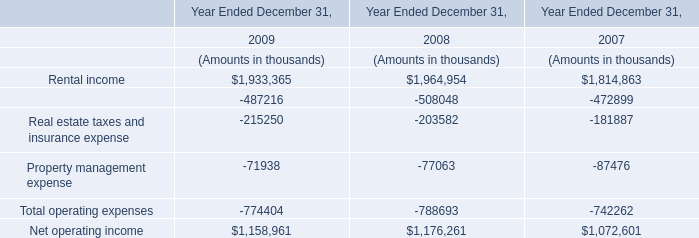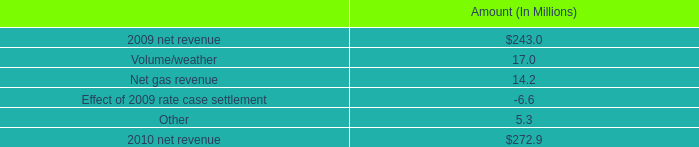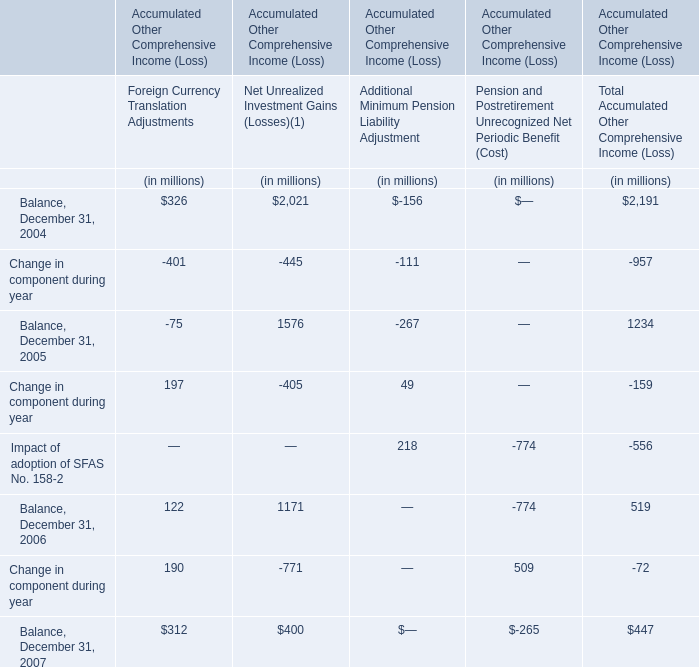What's the sum of all Change in component during year that are positive in 2005? (in million) 
Computations: (197 + 49)
Answer: 246.0. 